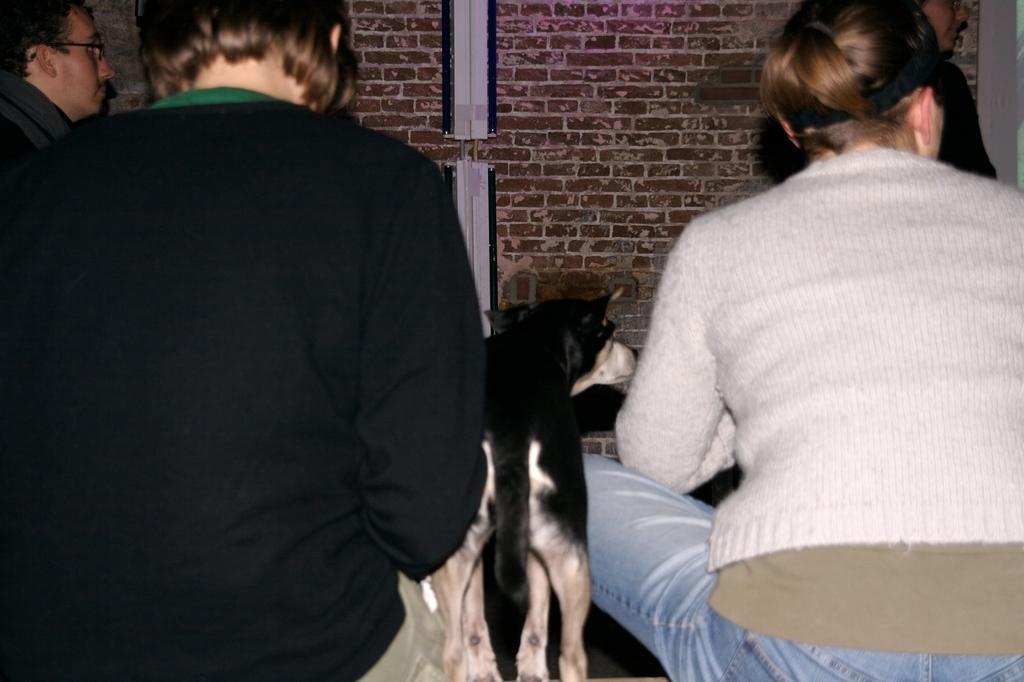How would you summarize this image in a sentence or two? In the picture we can see two women are sitting and in between them we can see a dog is standing and beside the women we can see a face of the man and in the background we can see the wall with bricks. 